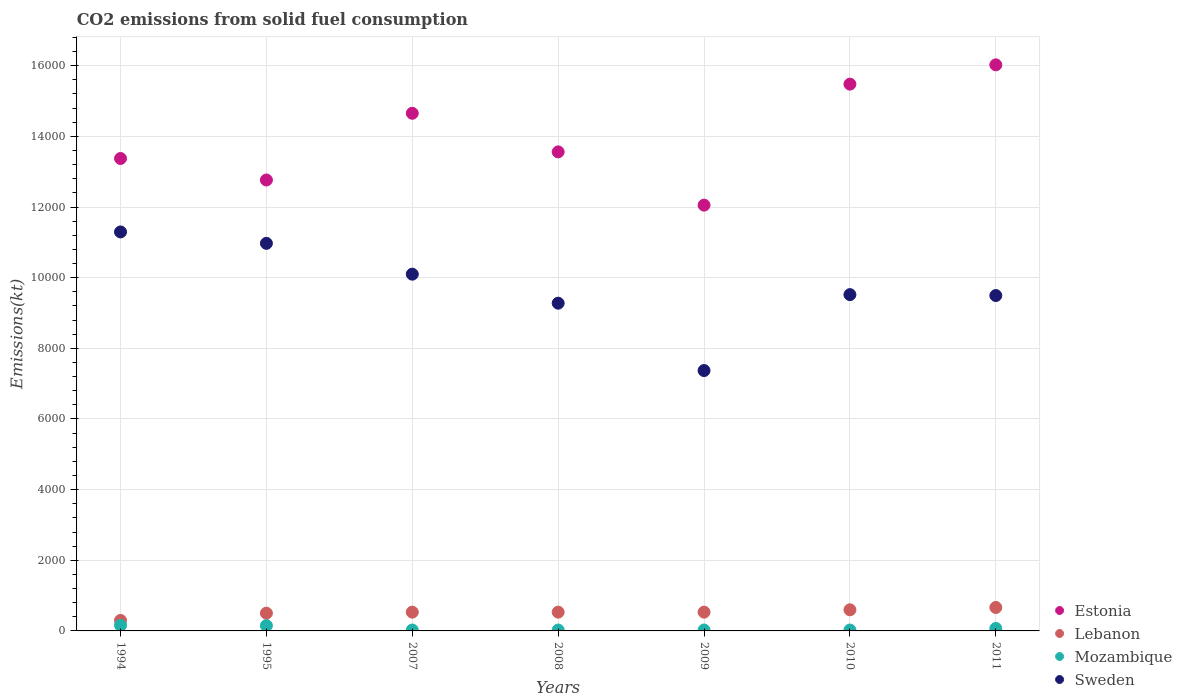How many different coloured dotlines are there?
Offer a terse response. 4. Is the number of dotlines equal to the number of legend labels?
Provide a short and direct response. Yes. What is the amount of CO2 emitted in Estonia in 2008?
Keep it short and to the point. 1.36e+04. Across all years, what is the maximum amount of CO2 emitted in Estonia?
Give a very brief answer. 1.60e+04. Across all years, what is the minimum amount of CO2 emitted in Lebanon?
Make the answer very short. 297.03. In which year was the amount of CO2 emitted in Lebanon minimum?
Offer a terse response. 1994. What is the total amount of CO2 emitted in Sweden in the graph?
Provide a short and direct response. 6.80e+04. What is the difference between the amount of CO2 emitted in Sweden in 2007 and that in 2008?
Your answer should be very brief. 821.41. What is the difference between the amount of CO2 emitted in Sweden in 2011 and the amount of CO2 emitted in Estonia in 2010?
Your answer should be compact. -5984.54. What is the average amount of CO2 emitted in Mozambique per year?
Provide a short and direct response. 68.63. In the year 2008, what is the difference between the amount of CO2 emitted in Estonia and amount of CO2 emitted in Lebanon?
Your answer should be compact. 1.30e+04. In how many years, is the amount of CO2 emitted in Lebanon greater than 8000 kt?
Provide a short and direct response. 0. What is the ratio of the amount of CO2 emitted in Mozambique in 2008 to that in 2010?
Your answer should be compact. 1. Is the amount of CO2 emitted in Mozambique in 2008 less than that in 2011?
Your answer should be very brief. Yes. What is the difference between the highest and the second highest amount of CO2 emitted in Sweden?
Offer a terse response. 322.7. What is the difference between the highest and the lowest amount of CO2 emitted in Sweden?
Offer a very short reply. 3923.69. In how many years, is the amount of CO2 emitted in Sweden greater than the average amount of CO2 emitted in Sweden taken over all years?
Keep it short and to the point. 3. Is the sum of the amount of CO2 emitted in Sweden in 2008 and 2011 greater than the maximum amount of CO2 emitted in Estonia across all years?
Offer a terse response. Yes. Does the amount of CO2 emitted in Estonia monotonically increase over the years?
Give a very brief answer. No. Is the amount of CO2 emitted in Mozambique strictly less than the amount of CO2 emitted in Sweden over the years?
Provide a short and direct response. Yes. How many dotlines are there?
Your answer should be very brief. 4. Does the graph contain any zero values?
Offer a terse response. No. Does the graph contain grids?
Offer a terse response. Yes. Where does the legend appear in the graph?
Offer a terse response. Bottom right. How many legend labels are there?
Offer a very short reply. 4. How are the legend labels stacked?
Provide a short and direct response. Vertical. What is the title of the graph?
Give a very brief answer. CO2 emissions from solid fuel consumption. What is the label or title of the Y-axis?
Provide a succinct answer. Emissions(kt). What is the Emissions(kt) of Estonia in 1994?
Your answer should be compact. 1.34e+04. What is the Emissions(kt) of Lebanon in 1994?
Your response must be concise. 297.03. What is the Emissions(kt) in Mozambique in 1994?
Offer a very short reply. 157.68. What is the Emissions(kt) of Sweden in 1994?
Provide a short and direct response. 1.13e+04. What is the Emissions(kt) in Estonia in 1995?
Your answer should be compact. 1.28e+04. What is the Emissions(kt) of Lebanon in 1995?
Your response must be concise. 502.38. What is the Emissions(kt) in Mozambique in 1995?
Keep it short and to the point. 150.35. What is the Emissions(kt) of Sweden in 1995?
Offer a very short reply. 1.10e+04. What is the Emissions(kt) in Estonia in 2007?
Make the answer very short. 1.47e+04. What is the Emissions(kt) of Lebanon in 2007?
Offer a terse response. 531.72. What is the Emissions(kt) of Mozambique in 2007?
Give a very brief answer. 25.67. What is the Emissions(kt) in Sweden in 2007?
Your answer should be compact. 1.01e+04. What is the Emissions(kt) of Estonia in 2008?
Give a very brief answer. 1.36e+04. What is the Emissions(kt) in Lebanon in 2008?
Provide a succinct answer. 531.72. What is the Emissions(kt) of Mozambique in 2008?
Your response must be concise. 25.67. What is the Emissions(kt) in Sweden in 2008?
Keep it short and to the point. 9277.51. What is the Emissions(kt) in Estonia in 2009?
Provide a short and direct response. 1.21e+04. What is the Emissions(kt) in Lebanon in 2009?
Make the answer very short. 531.72. What is the Emissions(kt) in Mozambique in 2009?
Make the answer very short. 25.67. What is the Emissions(kt) in Sweden in 2009?
Your answer should be compact. 7370.67. What is the Emissions(kt) of Estonia in 2010?
Give a very brief answer. 1.55e+04. What is the Emissions(kt) of Lebanon in 2010?
Your response must be concise. 597.72. What is the Emissions(kt) of Mozambique in 2010?
Give a very brief answer. 25.67. What is the Emissions(kt) in Sweden in 2010?
Your answer should be compact. 9519.53. What is the Emissions(kt) of Estonia in 2011?
Provide a succinct answer. 1.60e+04. What is the Emissions(kt) in Lebanon in 2011?
Provide a succinct answer. 663.73. What is the Emissions(kt) of Mozambique in 2011?
Make the answer very short. 69.67. What is the Emissions(kt) in Sweden in 2011?
Give a very brief answer. 9493.86. Across all years, what is the maximum Emissions(kt) in Estonia?
Ensure brevity in your answer.  1.60e+04. Across all years, what is the maximum Emissions(kt) in Lebanon?
Provide a short and direct response. 663.73. Across all years, what is the maximum Emissions(kt) in Mozambique?
Provide a succinct answer. 157.68. Across all years, what is the maximum Emissions(kt) in Sweden?
Your response must be concise. 1.13e+04. Across all years, what is the minimum Emissions(kt) in Estonia?
Give a very brief answer. 1.21e+04. Across all years, what is the minimum Emissions(kt) in Lebanon?
Your answer should be very brief. 297.03. Across all years, what is the minimum Emissions(kt) of Mozambique?
Give a very brief answer. 25.67. Across all years, what is the minimum Emissions(kt) of Sweden?
Your answer should be very brief. 7370.67. What is the total Emissions(kt) in Estonia in the graph?
Give a very brief answer. 9.79e+04. What is the total Emissions(kt) of Lebanon in the graph?
Ensure brevity in your answer.  3656. What is the total Emissions(kt) in Mozambique in the graph?
Give a very brief answer. 480.38. What is the total Emissions(kt) of Sweden in the graph?
Keep it short and to the point. 6.80e+04. What is the difference between the Emissions(kt) of Estonia in 1994 and that in 1995?
Your response must be concise. 608.72. What is the difference between the Emissions(kt) in Lebanon in 1994 and that in 1995?
Make the answer very short. -205.35. What is the difference between the Emissions(kt) in Mozambique in 1994 and that in 1995?
Keep it short and to the point. 7.33. What is the difference between the Emissions(kt) of Sweden in 1994 and that in 1995?
Provide a succinct answer. 322.7. What is the difference between the Emissions(kt) in Estonia in 1994 and that in 2007?
Make the answer very short. -1279.78. What is the difference between the Emissions(kt) in Lebanon in 1994 and that in 2007?
Offer a very short reply. -234.69. What is the difference between the Emissions(kt) in Mozambique in 1994 and that in 2007?
Offer a very short reply. 132.01. What is the difference between the Emissions(kt) in Sweden in 1994 and that in 2007?
Offer a very short reply. 1195.44. What is the difference between the Emissions(kt) of Estonia in 1994 and that in 2008?
Make the answer very short. -187.02. What is the difference between the Emissions(kt) of Lebanon in 1994 and that in 2008?
Offer a terse response. -234.69. What is the difference between the Emissions(kt) of Mozambique in 1994 and that in 2008?
Offer a very short reply. 132.01. What is the difference between the Emissions(kt) in Sweden in 1994 and that in 2008?
Keep it short and to the point. 2016.85. What is the difference between the Emissions(kt) in Estonia in 1994 and that in 2009?
Keep it short and to the point. 1320.12. What is the difference between the Emissions(kt) in Lebanon in 1994 and that in 2009?
Ensure brevity in your answer.  -234.69. What is the difference between the Emissions(kt) of Mozambique in 1994 and that in 2009?
Offer a terse response. 132.01. What is the difference between the Emissions(kt) in Sweden in 1994 and that in 2009?
Your answer should be very brief. 3923.69. What is the difference between the Emissions(kt) of Estonia in 1994 and that in 2010?
Your answer should be compact. -2104.86. What is the difference between the Emissions(kt) in Lebanon in 1994 and that in 2010?
Offer a very short reply. -300.69. What is the difference between the Emissions(kt) of Mozambique in 1994 and that in 2010?
Your answer should be compact. 132.01. What is the difference between the Emissions(kt) in Sweden in 1994 and that in 2010?
Your answer should be compact. 1774.83. What is the difference between the Emissions(kt) in Estonia in 1994 and that in 2011?
Offer a terse response. -2651.24. What is the difference between the Emissions(kt) of Lebanon in 1994 and that in 2011?
Make the answer very short. -366.7. What is the difference between the Emissions(kt) in Mozambique in 1994 and that in 2011?
Ensure brevity in your answer.  88.01. What is the difference between the Emissions(kt) of Sweden in 1994 and that in 2011?
Keep it short and to the point. 1800.5. What is the difference between the Emissions(kt) in Estonia in 1995 and that in 2007?
Keep it short and to the point. -1888.51. What is the difference between the Emissions(kt) of Lebanon in 1995 and that in 2007?
Offer a very short reply. -29.34. What is the difference between the Emissions(kt) of Mozambique in 1995 and that in 2007?
Provide a succinct answer. 124.68. What is the difference between the Emissions(kt) in Sweden in 1995 and that in 2007?
Your response must be concise. 872.75. What is the difference between the Emissions(kt) of Estonia in 1995 and that in 2008?
Offer a very short reply. -795.74. What is the difference between the Emissions(kt) in Lebanon in 1995 and that in 2008?
Give a very brief answer. -29.34. What is the difference between the Emissions(kt) in Mozambique in 1995 and that in 2008?
Give a very brief answer. 124.68. What is the difference between the Emissions(kt) in Sweden in 1995 and that in 2008?
Offer a terse response. 1694.15. What is the difference between the Emissions(kt) in Estonia in 1995 and that in 2009?
Your answer should be compact. 711.4. What is the difference between the Emissions(kt) in Lebanon in 1995 and that in 2009?
Your response must be concise. -29.34. What is the difference between the Emissions(kt) in Mozambique in 1995 and that in 2009?
Your response must be concise. 124.68. What is the difference between the Emissions(kt) in Sweden in 1995 and that in 2009?
Provide a succinct answer. 3600.99. What is the difference between the Emissions(kt) in Estonia in 1995 and that in 2010?
Ensure brevity in your answer.  -2713.58. What is the difference between the Emissions(kt) in Lebanon in 1995 and that in 2010?
Your response must be concise. -95.34. What is the difference between the Emissions(kt) in Mozambique in 1995 and that in 2010?
Offer a terse response. 124.68. What is the difference between the Emissions(kt) in Sweden in 1995 and that in 2010?
Offer a terse response. 1452.13. What is the difference between the Emissions(kt) of Estonia in 1995 and that in 2011?
Ensure brevity in your answer.  -3259.96. What is the difference between the Emissions(kt) in Lebanon in 1995 and that in 2011?
Ensure brevity in your answer.  -161.35. What is the difference between the Emissions(kt) in Mozambique in 1995 and that in 2011?
Your answer should be very brief. 80.67. What is the difference between the Emissions(kt) in Sweden in 1995 and that in 2011?
Make the answer very short. 1477.8. What is the difference between the Emissions(kt) of Estonia in 2007 and that in 2008?
Your response must be concise. 1092.77. What is the difference between the Emissions(kt) in Mozambique in 2007 and that in 2008?
Offer a terse response. 0. What is the difference between the Emissions(kt) in Sweden in 2007 and that in 2008?
Provide a short and direct response. 821.41. What is the difference between the Emissions(kt) of Estonia in 2007 and that in 2009?
Your answer should be compact. 2599.9. What is the difference between the Emissions(kt) of Sweden in 2007 and that in 2009?
Offer a terse response. 2728.25. What is the difference between the Emissions(kt) of Estonia in 2007 and that in 2010?
Give a very brief answer. -825.08. What is the difference between the Emissions(kt) in Lebanon in 2007 and that in 2010?
Keep it short and to the point. -66.01. What is the difference between the Emissions(kt) in Mozambique in 2007 and that in 2010?
Offer a very short reply. 0. What is the difference between the Emissions(kt) of Sweden in 2007 and that in 2010?
Provide a short and direct response. 579.39. What is the difference between the Emissions(kt) in Estonia in 2007 and that in 2011?
Offer a terse response. -1371.46. What is the difference between the Emissions(kt) in Lebanon in 2007 and that in 2011?
Your answer should be compact. -132.01. What is the difference between the Emissions(kt) in Mozambique in 2007 and that in 2011?
Ensure brevity in your answer.  -44. What is the difference between the Emissions(kt) of Sweden in 2007 and that in 2011?
Your answer should be very brief. 605.05. What is the difference between the Emissions(kt) in Estonia in 2008 and that in 2009?
Offer a very short reply. 1507.14. What is the difference between the Emissions(kt) of Lebanon in 2008 and that in 2009?
Provide a succinct answer. 0. What is the difference between the Emissions(kt) in Mozambique in 2008 and that in 2009?
Provide a succinct answer. 0. What is the difference between the Emissions(kt) of Sweden in 2008 and that in 2009?
Your answer should be compact. 1906.84. What is the difference between the Emissions(kt) in Estonia in 2008 and that in 2010?
Offer a terse response. -1917.84. What is the difference between the Emissions(kt) of Lebanon in 2008 and that in 2010?
Make the answer very short. -66.01. What is the difference between the Emissions(kt) in Mozambique in 2008 and that in 2010?
Give a very brief answer. 0. What is the difference between the Emissions(kt) of Sweden in 2008 and that in 2010?
Offer a very short reply. -242.02. What is the difference between the Emissions(kt) of Estonia in 2008 and that in 2011?
Your answer should be compact. -2464.22. What is the difference between the Emissions(kt) of Lebanon in 2008 and that in 2011?
Give a very brief answer. -132.01. What is the difference between the Emissions(kt) of Mozambique in 2008 and that in 2011?
Your answer should be very brief. -44. What is the difference between the Emissions(kt) in Sweden in 2008 and that in 2011?
Provide a succinct answer. -216.35. What is the difference between the Emissions(kt) of Estonia in 2009 and that in 2010?
Make the answer very short. -3424.98. What is the difference between the Emissions(kt) in Lebanon in 2009 and that in 2010?
Ensure brevity in your answer.  -66.01. What is the difference between the Emissions(kt) of Sweden in 2009 and that in 2010?
Provide a succinct answer. -2148.86. What is the difference between the Emissions(kt) in Estonia in 2009 and that in 2011?
Your answer should be very brief. -3971.36. What is the difference between the Emissions(kt) in Lebanon in 2009 and that in 2011?
Give a very brief answer. -132.01. What is the difference between the Emissions(kt) of Mozambique in 2009 and that in 2011?
Your answer should be compact. -44. What is the difference between the Emissions(kt) of Sweden in 2009 and that in 2011?
Ensure brevity in your answer.  -2123.19. What is the difference between the Emissions(kt) of Estonia in 2010 and that in 2011?
Offer a very short reply. -546.38. What is the difference between the Emissions(kt) in Lebanon in 2010 and that in 2011?
Ensure brevity in your answer.  -66.01. What is the difference between the Emissions(kt) in Mozambique in 2010 and that in 2011?
Your answer should be compact. -44. What is the difference between the Emissions(kt) in Sweden in 2010 and that in 2011?
Your answer should be compact. 25.67. What is the difference between the Emissions(kt) in Estonia in 1994 and the Emissions(kt) in Lebanon in 1995?
Your answer should be compact. 1.29e+04. What is the difference between the Emissions(kt) in Estonia in 1994 and the Emissions(kt) in Mozambique in 1995?
Your answer should be very brief. 1.32e+04. What is the difference between the Emissions(kt) in Estonia in 1994 and the Emissions(kt) in Sweden in 1995?
Provide a succinct answer. 2401.89. What is the difference between the Emissions(kt) of Lebanon in 1994 and the Emissions(kt) of Mozambique in 1995?
Provide a short and direct response. 146.68. What is the difference between the Emissions(kt) of Lebanon in 1994 and the Emissions(kt) of Sweden in 1995?
Offer a very short reply. -1.07e+04. What is the difference between the Emissions(kt) in Mozambique in 1994 and the Emissions(kt) in Sweden in 1995?
Ensure brevity in your answer.  -1.08e+04. What is the difference between the Emissions(kt) of Estonia in 1994 and the Emissions(kt) of Lebanon in 2007?
Keep it short and to the point. 1.28e+04. What is the difference between the Emissions(kt) in Estonia in 1994 and the Emissions(kt) in Mozambique in 2007?
Give a very brief answer. 1.33e+04. What is the difference between the Emissions(kt) of Estonia in 1994 and the Emissions(kt) of Sweden in 2007?
Offer a very short reply. 3274.63. What is the difference between the Emissions(kt) of Lebanon in 1994 and the Emissions(kt) of Mozambique in 2007?
Give a very brief answer. 271.36. What is the difference between the Emissions(kt) of Lebanon in 1994 and the Emissions(kt) of Sweden in 2007?
Offer a terse response. -9801.89. What is the difference between the Emissions(kt) of Mozambique in 1994 and the Emissions(kt) of Sweden in 2007?
Offer a very short reply. -9941.24. What is the difference between the Emissions(kt) in Estonia in 1994 and the Emissions(kt) in Lebanon in 2008?
Your response must be concise. 1.28e+04. What is the difference between the Emissions(kt) in Estonia in 1994 and the Emissions(kt) in Mozambique in 2008?
Keep it short and to the point. 1.33e+04. What is the difference between the Emissions(kt) of Estonia in 1994 and the Emissions(kt) of Sweden in 2008?
Ensure brevity in your answer.  4096.04. What is the difference between the Emissions(kt) in Lebanon in 1994 and the Emissions(kt) in Mozambique in 2008?
Ensure brevity in your answer.  271.36. What is the difference between the Emissions(kt) of Lebanon in 1994 and the Emissions(kt) of Sweden in 2008?
Ensure brevity in your answer.  -8980.48. What is the difference between the Emissions(kt) in Mozambique in 1994 and the Emissions(kt) in Sweden in 2008?
Give a very brief answer. -9119.83. What is the difference between the Emissions(kt) in Estonia in 1994 and the Emissions(kt) in Lebanon in 2009?
Give a very brief answer. 1.28e+04. What is the difference between the Emissions(kt) in Estonia in 1994 and the Emissions(kt) in Mozambique in 2009?
Provide a succinct answer. 1.33e+04. What is the difference between the Emissions(kt) of Estonia in 1994 and the Emissions(kt) of Sweden in 2009?
Your response must be concise. 6002.88. What is the difference between the Emissions(kt) in Lebanon in 1994 and the Emissions(kt) in Mozambique in 2009?
Give a very brief answer. 271.36. What is the difference between the Emissions(kt) of Lebanon in 1994 and the Emissions(kt) of Sweden in 2009?
Provide a short and direct response. -7073.64. What is the difference between the Emissions(kt) in Mozambique in 1994 and the Emissions(kt) in Sweden in 2009?
Ensure brevity in your answer.  -7212.99. What is the difference between the Emissions(kt) in Estonia in 1994 and the Emissions(kt) in Lebanon in 2010?
Your response must be concise. 1.28e+04. What is the difference between the Emissions(kt) in Estonia in 1994 and the Emissions(kt) in Mozambique in 2010?
Offer a very short reply. 1.33e+04. What is the difference between the Emissions(kt) of Estonia in 1994 and the Emissions(kt) of Sweden in 2010?
Provide a succinct answer. 3854.02. What is the difference between the Emissions(kt) in Lebanon in 1994 and the Emissions(kt) in Mozambique in 2010?
Provide a short and direct response. 271.36. What is the difference between the Emissions(kt) of Lebanon in 1994 and the Emissions(kt) of Sweden in 2010?
Offer a very short reply. -9222.5. What is the difference between the Emissions(kt) of Mozambique in 1994 and the Emissions(kt) of Sweden in 2010?
Provide a succinct answer. -9361.85. What is the difference between the Emissions(kt) in Estonia in 1994 and the Emissions(kt) in Lebanon in 2011?
Keep it short and to the point. 1.27e+04. What is the difference between the Emissions(kt) in Estonia in 1994 and the Emissions(kt) in Mozambique in 2011?
Ensure brevity in your answer.  1.33e+04. What is the difference between the Emissions(kt) in Estonia in 1994 and the Emissions(kt) in Sweden in 2011?
Provide a succinct answer. 3879.69. What is the difference between the Emissions(kt) of Lebanon in 1994 and the Emissions(kt) of Mozambique in 2011?
Give a very brief answer. 227.35. What is the difference between the Emissions(kt) in Lebanon in 1994 and the Emissions(kt) in Sweden in 2011?
Give a very brief answer. -9196.84. What is the difference between the Emissions(kt) in Mozambique in 1994 and the Emissions(kt) in Sweden in 2011?
Offer a terse response. -9336.18. What is the difference between the Emissions(kt) of Estonia in 1995 and the Emissions(kt) of Lebanon in 2007?
Provide a succinct answer. 1.22e+04. What is the difference between the Emissions(kt) of Estonia in 1995 and the Emissions(kt) of Mozambique in 2007?
Provide a short and direct response. 1.27e+04. What is the difference between the Emissions(kt) of Estonia in 1995 and the Emissions(kt) of Sweden in 2007?
Provide a succinct answer. 2665.91. What is the difference between the Emissions(kt) of Lebanon in 1995 and the Emissions(kt) of Mozambique in 2007?
Give a very brief answer. 476.71. What is the difference between the Emissions(kt) in Lebanon in 1995 and the Emissions(kt) in Sweden in 2007?
Make the answer very short. -9596.54. What is the difference between the Emissions(kt) of Mozambique in 1995 and the Emissions(kt) of Sweden in 2007?
Your answer should be very brief. -9948.57. What is the difference between the Emissions(kt) of Estonia in 1995 and the Emissions(kt) of Lebanon in 2008?
Provide a succinct answer. 1.22e+04. What is the difference between the Emissions(kt) in Estonia in 1995 and the Emissions(kt) in Mozambique in 2008?
Provide a short and direct response. 1.27e+04. What is the difference between the Emissions(kt) in Estonia in 1995 and the Emissions(kt) in Sweden in 2008?
Provide a succinct answer. 3487.32. What is the difference between the Emissions(kt) of Lebanon in 1995 and the Emissions(kt) of Mozambique in 2008?
Provide a short and direct response. 476.71. What is the difference between the Emissions(kt) in Lebanon in 1995 and the Emissions(kt) in Sweden in 2008?
Offer a very short reply. -8775.13. What is the difference between the Emissions(kt) of Mozambique in 1995 and the Emissions(kt) of Sweden in 2008?
Keep it short and to the point. -9127.16. What is the difference between the Emissions(kt) in Estonia in 1995 and the Emissions(kt) in Lebanon in 2009?
Offer a terse response. 1.22e+04. What is the difference between the Emissions(kt) in Estonia in 1995 and the Emissions(kt) in Mozambique in 2009?
Your answer should be compact. 1.27e+04. What is the difference between the Emissions(kt) of Estonia in 1995 and the Emissions(kt) of Sweden in 2009?
Give a very brief answer. 5394.16. What is the difference between the Emissions(kt) in Lebanon in 1995 and the Emissions(kt) in Mozambique in 2009?
Your answer should be compact. 476.71. What is the difference between the Emissions(kt) in Lebanon in 1995 and the Emissions(kt) in Sweden in 2009?
Keep it short and to the point. -6868.29. What is the difference between the Emissions(kt) of Mozambique in 1995 and the Emissions(kt) of Sweden in 2009?
Give a very brief answer. -7220.32. What is the difference between the Emissions(kt) of Estonia in 1995 and the Emissions(kt) of Lebanon in 2010?
Your answer should be compact. 1.22e+04. What is the difference between the Emissions(kt) of Estonia in 1995 and the Emissions(kt) of Mozambique in 2010?
Give a very brief answer. 1.27e+04. What is the difference between the Emissions(kt) of Estonia in 1995 and the Emissions(kt) of Sweden in 2010?
Make the answer very short. 3245.3. What is the difference between the Emissions(kt) of Lebanon in 1995 and the Emissions(kt) of Mozambique in 2010?
Provide a short and direct response. 476.71. What is the difference between the Emissions(kt) in Lebanon in 1995 and the Emissions(kt) in Sweden in 2010?
Provide a short and direct response. -9017.15. What is the difference between the Emissions(kt) of Mozambique in 1995 and the Emissions(kt) of Sweden in 2010?
Your answer should be compact. -9369.18. What is the difference between the Emissions(kt) of Estonia in 1995 and the Emissions(kt) of Lebanon in 2011?
Your response must be concise. 1.21e+04. What is the difference between the Emissions(kt) in Estonia in 1995 and the Emissions(kt) in Mozambique in 2011?
Your answer should be very brief. 1.27e+04. What is the difference between the Emissions(kt) in Estonia in 1995 and the Emissions(kt) in Sweden in 2011?
Your answer should be very brief. 3270.96. What is the difference between the Emissions(kt) of Lebanon in 1995 and the Emissions(kt) of Mozambique in 2011?
Your answer should be very brief. 432.71. What is the difference between the Emissions(kt) in Lebanon in 1995 and the Emissions(kt) in Sweden in 2011?
Offer a very short reply. -8991.48. What is the difference between the Emissions(kt) of Mozambique in 1995 and the Emissions(kt) of Sweden in 2011?
Ensure brevity in your answer.  -9343.52. What is the difference between the Emissions(kt) in Estonia in 2007 and the Emissions(kt) in Lebanon in 2008?
Provide a short and direct response. 1.41e+04. What is the difference between the Emissions(kt) in Estonia in 2007 and the Emissions(kt) in Mozambique in 2008?
Provide a short and direct response. 1.46e+04. What is the difference between the Emissions(kt) of Estonia in 2007 and the Emissions(kt) of Sweden in 2008?
Your answer should be compact. 5375.82. What is the difference between the Emissions(kt) of Lebanon in 2007 and the Emissions(kt) of Mozambique in 2008?
Provide a succinct answer. 506.05. What is the difference between the Emissions(kt) in Lebanon in 2007 and the Emissions(kt) in Sweden in 2008?
Provide a succinct answer. -8745.8. What is the difference between the Emissions(kt) of Mozambique in 2007 and the Emissions(kt) of Sweden in 2008?
Your answer should be compact. -9251.84. What is the difference between the Emissions(kt) of Estonia in 2007 and the Emissions(kt) of Lebanon in 2009?
Offer a terse response. 1.41e+04. What is the difference between the Emissions(kt) in Estonia in 2007 and the Emissions(kt) in Mozambique in 2009?
Keep it short and to the point. 1.46e+04. What is the difference between the Emissions(kt) in Estonia in 2007 and the Emissions(kt) in Sweden in 2009?
Your response must be concise. 7282.66. What is the difference between the Emissions(kt) of Lebanon in 2007 and the Emissions(kt) of Mozambique in 2009?
Give a very brief answer. 506.05. What is the difference between the Emissions(kt) of Lebanon in 2007 and the Emissions(kt) of Sweden in 2009?
Your answer should be compact. -6838.95. What is the difference between the Emissions(kt) in Mozambique in 2007 and the Emissions(kt) in Sweden in 2009?
Offer a terse response. -7345. What is the difference between the Emissions(kt) in Estonia in 2007 and the Emissions(kt) in Lebanon in 2010?
Keep it short and to the point. 1.41e+04. What is the difference between the Emissions(kt) of Estonia in 2007 and the Emissions(kt) of Mozambique in 2010?
Your response must be concise. 1.46e+04. What is the difference between the Emissions(kt) in Estonia in 2007 and the Emissions(kt) in Sweden in 2010?
Your answer should be compact. 5133.8. What is the difference between the Emissions(kt) in Lebanon in 2007 and the Emissions(kt) in Mozambique in 2010?
Provide a succinct answer. 506.05. What is the difference between the Emissions(kt) of Lebanon in 2007 and the Emissions(kt) of Sweden in 2010?
Give a very brief answer. -8987.82. What is the difference between the Emissions(kt) in Mozambique in 2007 and the Emissions(kt) in Sweden in 2010?
Offer a terse response. -9493.86. What is the difference between the Emissions(kt) in Estonia in 2007 and the Emissions(kt) in Lebanon in 2011?
Your response must be concise. 1.40e+04. What is the difference between the Emissions(kt) of Estonia in 2007 and the Emissions(kt) of Mozambique in 2011?
Provide a succinct answer. 1.46e+04. What is the difference between the Emissions(kt) of Estonia in 2007 and the Emissions(kt) of Sweden in 2011?
Provide a succinct answer. 5159.47. What is the difference between the Emissions(kt) in Lebanon in 2007 and the Emissions(kt) in Mozambique in 2011?
Your answer should be compact. 462.04. What is the difference between the Emissions(kt) of Lebanon in 2007 and the Emissions(kt) of Sweden in 2011?
Your answer should be compact. -8962.15. What is the difference between the Emissions(kt) of Mozambique in 2007 and the Emissions(kt) of Sweden in 2011?
Keep it short and to the point. -9468.19. What is the difference between the Emissions(kt) of Estonia in 2008 and the Emissions(kt) of Lebanon in 2009?
Ensure brevity in your answer.  1.30e+04. What is the difference between the Emissions(kt) of Estonia in 2008 and the Emissions(kt) of Mozambique in 2009?
Give a very brief answer. 1.35e+04. What is the difference between the Emissions(kt) of Estonia in 2008 and the Emissions(kt) of Sweden in 2009?
Your response must be concise. 6189.9. What is the difference between the Emissions(kt) in Lebanon in 2008 and the Emissions(kt) in Mozambique in 2009?
Ensure brevity in your answer.  506.05. What is the difference between the Emissions(kt) of Lebanon in 2008 and the Emissions(kt) of Sweden in 2009?
Offer a terse response. -6838.95. What is the difference between the Emissions(kt) in Mozambique in 2008 and the Emissions(kt) in Sweden in 2009?
Give a very brief answer. -7345. What is the difference between the Emissions(kt) of Estonia in 2008 and the Emissions(kt) of Lebanon in 2010?
Make the answer very short. 1.30e+04. What is the difference between the Emissions(kt) of Estonia in 2008 and the Emissions(kt) of Mozambique in 2010?
Offer a very short reply. 1.35e+04. What is the difference between the Emissions(kt) in Estonia in 2008 and the Emissions(kt) in Sweden in 2010?
Offer a terse response. 4041.03. What is the difference between the Emissions(kt) of Lebanon in 2008 and the Emissions(kt) of Mozambique in 2010?
Offer a terse response. 506.05. What is the difference between the Emissions(kt) in Lebanon in 2008 and the Emissions(kt) in Sweden in 2010?
Offer a terse response. -8987.82. What is the difference between the Emissions(kt) in Mozambique in 2008 and the Emissions(kt) in Sweden in 2010?
Your response must be concise. -9493.86. What is the difference between the Emissions(kt) in Estonia in 2008 and the Emissions(kt) in Lebanon in 2011?
Give a very brief answer. 1.29e+04. What is the difference between the Emissions(kt) of Estonia in 2008 and the Emissions(kt) of Mozambique in 2011?
Make the answer very short. 1.35e+04. What is the difference between the Emissions(kt) of Estonia in 2008 and the Emissions(kt) of Sweden in 2011?
Keep it short and to the point. 4066.7. What is the difference between the Emissions(kt) of Lebanon in 2008 and the Emissions(kt) of Mozambique in 2011?
Offer a very short reply. 462.04. What is the difference between the Emissions(kt) in Lebanon in 2008 and the Emissions(kt) in Sweden in 2011?
Your response must be concise. -8962.15. What is the difference between the Emissions(kt) of Mozambique in 2008 and the Emissions(kt) of Sweden in 2011?
Offer a very short reply. -9468.19. What is the difference between the Emissions(kt) in Estonia in 2009 and the Emissions(kt) in Lebanon in 2010?
Make the answer very short. 1.15e+04. What is the difference between the Emissions(kt) in Estonia in 2009 and the Emissions(kt) in Mozambique in 2010?
Offer a terse response. 1.20e+04. What is the difference between the Emissions(kt) of Estonia in 2009 and the Emissions(kt) of Sweden in 2010?
Ensure brevity in your answer.  2533.9. What is the difference between the Emissions(kt) of Lebanon in 2009 and the Emissions(kt) of Mozambique in 2010?
Offer a terse response. 506.05. What is the difference between the Emissions(kt) in Lebanon in 2009 and the Emissions(kt) in Sweden in 2010?
Give a very brief answer. -8987.82. What is the difference between the Emissions(kt) in Mozambique in 2009 and the Emissions(kt) in Sweden in 2010?
Offer a terse response. -9493.86. What is the difference between the Emissions(kt) in Estonia in 2009 and the Emissions(kt) in Lebanon in 2011?
Provide a succinct answer. 1.14e+04. What is the difference between the Emissions(kt) in Estonia in 2009 and the Emissions(kt) in Mozambique in 2011?
Offer a very short reply. 1.20e+04. What is the difference between the Emissions(kt) in Estonia in 2009 and the Emissions(kt) in Sweden in 2011?
Provide a succinct answer. 2559.57. What is the difference between the Emissions(kt) of Lebanon in 2009 and the Emissions(kt) of Mozambique in 2011?
Offer a very short reply. 462.04. What is the difference between the Emissions(kt) in Lebanon in 2009 and the Emissions(kt) in Sweden in 2011?
Ensure brevity in your answer.  -8962.15. What is the difference between the Emissions(kt) of Mozambique in 2009 and the Emissions(kt) of Sweden in 2011?
Give a very brief answer. -9468.19. What is the difference between the Emissions(kt) of Estonia in 2010 and the Emissions(kt) of Lebanon in 2011?
Your response must be concise. 1.48e+04. What is the difference between the Emissions(kt) of Estonia in 2010 and the Emissions(kt) of Mozambique in 2011?
Give a very brief answer. 1.54e+04. What is the difference between the Emissions(kt) in Estonia in 2010 and the Emissions(kt) in Sweden in 2011?
Your answer should be very brief. 5984.54. What is the difference between the Emissions(kt) in Lebanon in 2010 and the Emissions(kt) in Mozambique in 2011?
Make the answer very short. 528.05. What is the difference between the Emissions(kt) of Lebanon in 2010 and the Emissions(kt) of Sweden in 2011?
Your answer should be compact. -8896.14. What is the difference between the Emissions(kt) of Mozambique in 2010 and the Emissions(kt) of Sweden in 2011?
Ensure brevity in your answer.  -9468.19. What is the average Emissions(kt) in Estonia per year?
Offer a very short reply. 1.40e+04. What is the average Emissions(kt) in Lebanon per year?
Make the answer very short. 522.29. What is the average Emissions(kt) of Mozambique per year?
Provide a short and direct response. 68.63. What is the average Emissions(kt) in Sweden per year?
Ensure brevity in your answer.  9718.07. In the year 1994, what is the difference between the Emissions(kt) of Estonia and Emissions(kt) of Lebanon?
Your answer should be very brief. 1.31e+04. In the year 1994, what is the difference between the Emissions(kt) of Estonia and Emissions(kt) of Mozambique?
Your answer should be compact. 1.32e+04. In the year 1994, what is the difference between the Emissions(kt) in Estonia and Emissions(kt) in Sweden?
Offer a very short reply. 2079.19. In the year 1994, what is the difference between the Emissions(kt) of Lebanon and Emissions(kt) of Mozambique?
Keep it short and to the point. 139.35. In the year 1994, what is the difference between the Emissions(kt) in Lebanon and Emissions(kt) in Sweden?
Ensure brevity in your answer.  -1.10e+04. In the year 1994, what is the difference between the Emissions(kt) in Mozambique and Emissions(kt) in Sweden?
Your answer should be very brief. -1.11e+04. In the year 1995, what is the difference between the Emissions(kt) in Estonia and Emissions(kt) in Lebanon?
Give a very brief answer. 1.23e+04. In the year 1995, what is the difference between the Emissions(kt) of Estonia and Emissions(kt) of Mozambique?
Provide a short and direct response. 1.26e+04. In the year 1995, what is the difference between the Emissions(kt) of Estonia and Emissions(kt) of Sweden?
Make the answer very short. 1793.16. In the year 1995, what is the difference between the Emissions(kt) in Lebanon and Emissions(kt) in Mozambique?
Your answer should be very brief. 352.03. In the year 1995, what is the difference between the Emissions(kt) of Lebanon and Emissions(kt) of Sweden?
Ensure brevity in your answer.  -1.05e+04. In the year 1995, what is the difference between the Emissions(kt) of Mozambique and Emissions(kt) of Sweden?
Your answer should be very brief. -1.08e+04. In the year 2007, what is the difference between the Emissions(kt) in Estonia and Emissions(kt) in Lebanon?
Keep it short and to the point. 1.41e+04. In the year 2007, what is the difference between the Emissions(kt) in Estonia and Emissions(kt) in Mozambique?
Keep it short and to the point. 1.46e+04. In the year 2007, what is the difference between the Emissions(kt) in Estonia and Emissions(kt) in Sweden?
Provide a short and direct response. 4554.41. In the year 2007, what is the difference between the Emissions(kt) in Lebanon and Emissions(kt) in Mozambique?
Your answer should be very brief. 506.05. In the year 2007, what is the difference between the Emissions(kt) in Lebanon and Emissions(kt) in Sweden?
Offer a terse response. -9567.2. In the year 2007, what is the difference between the Emissions(kt) in Mozambique and Emissions(kt) in Sweden?
Ensure brevity in your answer.  -1.01e+04. In the year 2008, what is the difference between the Emissions(kt) of Estonia and Emissions(kt) of Lebanon?
Offer a terse response. 1.30e+04. In the year 2008, what is the difference between the Emissions(kt) of Estonia and Emissions(kt) of Mozambique?
Provide a succinct answer. 1.35e+04. In the year 2008, what is the difference between the Emissions(kt) of Estonia and Emissions(kt) of Sweden?
Offer a very short reply. 4283.06. In the year 2008, what is the difference between the Emissions(kt) in Lebanon and Emissions(kt) in Mozambique?
Your answer should be compact. 506.05. In the year 2008, what is the difference between the Emissions(kt) in Lebanon and Emissions(kt) in Sweden?
Offer a very short reply. -8745.8. In the year 2008, what is the difference between the Emissions(kt) in Mozambique and Emissions(kt) in Sweden?
Ensure brevity in your answer.  -9251.84. In the year 2009, what is the difference between the Emissions(kt) in Estonia and Emissions(kt) in Lebanon?
Offer a very short reply. 1.15e+04. In the year 2009, what is the difference between the Emissions(kt) in Estonia and Emissions(kt) in Mozambique?
Make the answer very short. 1.20e+04. In the year 2009, what is the difference between the Emissions(kt) of Estonia and Emissions(kt) of Sweden?
Offer a terse response. 4682.76. In the year 2009, what is the difference between the Emissions(kt) in Lebanon and Emissions(kt) in Mozambique?
Provide a short and direct response. 506.05. In the year 2009, what is the difference between the Emissions(kt) of Lebanon and Emissions(kt) of Sweden?
Make the answer very short. -6838.95. In the year 2009, what is the difference between the Emissions(kt) in Mozambique and Emissions(kt) in Sweden?
Keep it short and to the point. -7345. In the year 2010, what is the difference between the Emissions(kt) in Estonia and Emissions(kt) in Lebanon?
Offer a terse response. 1.49e+04. In the year 2010, what is the difference between the Emissions(kt) of Estonia and Emissions(kt) of Mozambique?
Your response must be concise. 1.55e+04. In the year 2010, what is the difference between the Emissions(kt) of Estonia and Emissions(kt) of Sweden?
Provide a succinct answer. 5958.88. In the year 2010, what is the difference between the Emissions(kt) of Lebanon and Emissions(kt) of Mozambique?
Make the answer very short. 572.05. In the year 2010, what is the difference between the Emissions(kt) of Lebanon and Emissions(kt) of Sweden?
Your answer should be compact. -8921.81. In the year 2010, what is the difference between the Emissions(kt) in Mozambique and Emissions(kt) in Sweden?
Your answer should be compact. -9493.86. In the year 2011, what is the difference between the Emissions(kt) of Estonia and Emissions(kt) of Lebanon?
Your answer should be compact. 1.54e+04. In the year 2011, what is the difference between the Emissions(kt) of Estonia and Emissions(kt) of Mozambique?
Your response must be concise. 1.60e+04. In the year 2011, what is the difference between the Emissions(kt) in Estonia and Emissions(kt) in Sweden?
Provide a short and direct response. 6530.93. In the year 2011, what is the difference between the Emissions(kt) in Lebanon and Emissions(kt) in Mozambique?
Provide a short and direct response. 594.05. In the year 2011, what is the difference between the Emissions(kt) of Lebanon and Emissions(kt) of Sweden?
Ensure brevity in your answer.  -8830.14. In the year 2011, what is the difference between the Emissions(kt) in Mozambique and Emissions(kt) in Sweden?
Offer a very short reply. -9424.19. What is the ratio of the Emissions(kt) in Estonia in 1994 to that in 1995?
Ensure brevity in your answer.  1.05. What is the ratio of the Emissions(kt) of Lebanon in 1994 to that in 1995?
Make the answer very short. 0.59. What is the ratio of the Emissions(kt) of Mozambique in 1994 to that in 1995?
Your answer should be very brief. 1.05. What is the ratio of the Emissions(kt) of Sweden in 1994 to that in 1995?
Provide a short and direct response. 1.03. What is the ratio of the Emissions(kt) in Estonia in 1994 to that in 2007?
Make the answer very short. 0.91. What is the ratio of the Emissions(kt) in Lebanon in 1994 to that in 2007?
Your answer should be compact. 0.56. What is the ratio of the Emissions(kt) in Mozambique in 1994 to that in 2007?
Provide a succinct answer. 6.14. What is the ratio of the Emissions(kt) of Sweden in 1994 to that in 2007?
Offer a very short reply. 1.12. What is the ratio of the Emissions(kt) in Estonia in 1994 to that in 2008?
Give a very brief answer. 0.99. What is the ratio of the Emissions(kt) of Lebanon in 1994 to that in 2008?
Your answer should be compact. 0.56. What is the ratio of the Emissions(kt) of Mozambique in 1994 to that in 2008?
Provide a short and direct response. 6.14. What is the ratio of the Emissions(kt) in Sweden in 1994 to that in 2008?
Give a very brief answer. 1.22. What is the ratio of the Emissions(kt) in Estonia in 1994 to that in 2009?
Offer a terse response. 1.11. What is the ratio of the Emissions(kt) in Lebanon in 1994 to that in 2009?
Keep it short and to the point. 0.56. What is the ratio of the Emissions(kt) in Mozambique in 1994 to that in 2009?
Provide a short and direct response. 6.14. What is the ratio of the Emissions(kt) of Sweden in 1994 to that in 2009?
Make the answer very short. 1.53. What is the ratio of the Emissions(kt) in Estonia in 1994 to that in 2010?
Give a very brief answer. 0.86. What is the ratio of the Emissions(kt) in Lebanon in 1994 to that in 2010?
Your answer should be compact. 0.5. What is the ratio of the Emissions(kt) of Mozambique in 1994 to that in 2010?
Give a very brief answer. 6.14. What is the ratio of the Emissions(kt) of Sweden in 1994 to that in 2010?
Offer a very short reply. 1.19. What is the ratio of the Emissions(kt) in Estonia in 1994 to that in 2011?
Your response must be concise. 0.83. What is the ratio of the Emissions(kt) in Lebanon in 1994 to that in 2011?
Provide a short and direct response. 0.45. What is the ratio of the Emissions(kt) of Mozambique in 1994 to that in 2011?
Keep it short and to the point. 2.26. What is the ratio of the Emissions(kt) of Sweden in 1994 to that in 2011?
Offer a terse response. 1.19. What is the ratio of the Emissions(kt) in Estonia in 1995 to that in 2007?
Make the answer very short. 0.87. What is the ratio of the Emissions(kt) of Lebanon in 1995 to that in 2007?
Offer a terse response. 0.94. What is the ratio of the Emissions(kt) of Mozambique in 1995 to that in 2007?
Your answer should be compact. 5.86. What is the ratio of the Emissions(kt) of Sweden in 1995 to that in 2007?
Your response must be concise. 1.09. What is the ratio of the Emissions(kt) of Estonia in 1995 to that in 2008?
Ensure brevity in your answer.  0.94. What is the ratio of the Emissions(kt) in Lebanon in 1995 to that in 2008?
Provide a short and direct response. 0.94. What is the ratio of the Emissions(kt) of Mozambique in 1995 to that in 2008?
Your response must be concise. 5.86. What is the ratio of the Emissions(kt) in Sweden in 1995 to that in 2008?
Give a very brief answer. 1.18. What is the ratio of the Emissions(kt) in Estonia in 1995 to that in 2009?
Offer a terse response. 1.06. What is the ratio of the Emissions(kt) in Lebanon in 1995 to that in 2009?
Provide a succinct answer. 0.94. What is the ratio of the Emissions(kt) of Mozambique in 1995 to that in 2009?
Make the answer very short. 5.86. What is the ratio of the Emissions(kt) of Sweden in 1995 to that in 2009?
Your response must be concise. 1.49. What is the ratio of the Emissions(kt) of Estonia in 1995 to that in 2010?
Ensure brevity in your answer.  0.82. What is the ratio of the Emissions(kt) in Lebanon in 1995 to that in 2010?
Give a very brief answer. 0.84. What is the ratio of the Emissions(kt) in Mozambique in 1995 to that in 2010?
Keep it short and to the point. 5.86. What is the ratio of the Emissions(kt) in Sweden in 1995 to that in 2010?
Offer a terse response. 1.15. What is the ratio of the Emissions(kt) of Estonia in 1995 to that in 2011?
Ensure brevity in your answer.  0.8. What is the ratio of the Emissions(kt) of Lebanon in 1995 to that in 2011?
Ensure brevity in your answer.  0.76. What is the ratio of the Emissions(kt) of Mozambique in 1995 to that in 2011?
Give a very brief answer. 2.16. What is the ratio of the Emissions(kt) in Sweden in 1995 to that in 2011?
Offer a very short reply. 1.16. What is the ratio of the Emissions(kt) in Estonia in 2007 to that in 2008?
Make the answer very short. 1.08. What is the ratio of the Emissions(kt) of Lebanon in 2007 to that in 2008?
Keep it short and to the point. 1. What is the ratio of the Emissions(kt) of Mozambique in 2007 to that in 2008?
Your answer should be compact. 1. What is the ratio of the Emissions(kt) in Sweden in 2007 to that in 2008?
Make the answer very short. 1.09. What is the ratio of the Emissions(kt) in Estonia in 2007 to that in 2009?
Make the answer very short. 1.22. What is the ratio of the Emissions(kt) in Sweden in 2007 to that in 2009?
Your answer should be compact. 1.37. What is the ratio of the Emissions(kt) of Estonia in 2007 to that in 2010?
Offer a very short reply. 0.95. What is the ratio of the Emissions(kt) of Lebanon in 2007 to that in 2010?
Your answer should be very brief. 0.89. What is the ratio of the Emissions(kt) of Sweden in 2007 to that in 2010?
Your response must be concise. 1.06. What is the ratio of the Emissions(kt) of Estonia in 2007 to that in 2011?
Provide a short and direct response. 0.91. What is the ratio of the Emissions(kt) in Lebanon in 2007 to that in 2011?
Give a very brief answer. 0.8. What is the ratio of the Emissions(kt) in Mozambique in 2007 to that in 2011?
Your response must be concise. 0.37. What is the ratio of the Emissions(kt) in Sweden in 2007 to that in 2011?
Your answer should be compact. 1.06. What is the ratio of the Emissions(kt) in Estonia in 2008 to that in 2009?
Provide a succinct answer. 1.12. What is the ratio of the Emissions(kt) of Mozambique in 2008 to that in 2009?
Provide a short and direct response. 1. What is the ratio of the Emissions(kt) of Sweden in 2008 to that in 2009?
Provide a short and direct response. 1.26. What is the ratio of the Emissions(kt) of Estonia in 2008 to that in 2010?
Offer a terse response. 0.88. What is the ratio of the Emissions(kt) in Lebanon in 2008 to that in 2010?
Provide a short and direct response. 0.89. What is the ratio of the Emissions(kt) in Mozambique in 2008 to that in 2010?
Your response must be concise. 1. What is the ratio of the Emissions(kt) in Sweden in 2008 to that in 2010?
Give a very brief answer. 0.97. What is the ratio of the Emissions(kt) of Estonia in 2008 to that in 2011?
Ensure brevity in your answer.  0.85. What is the ratio of the Emissions(kt) of Lebanon in 2008 to that in 2011?
Ensure brevity in your answer.  0.8. What is the ratio of the Emissions(kt) in Mozambique in 2008 to that in 2011?
Provide a short and direct response. 0.37. What is the ratio of the Emissions(kt) of Sweden in 2008 to that in 2011?
Offer a terse response. 0.98. What is the ratio of the Emissions(kt) in Estonia in 2009 to that in 2010?
Offer a terse response. 0.78. What is the ratio of the Emissions(kt) in Lebanon in 2009 to that in 2010?
Provide a short and direct response. 0.89. What is the ratio of the Emissions(kt) in Mozambique in 2009 to that in 2010?
Your answer should be very brief. 1. What is the ratio of the Emissions(kt) in Sweden in 2009 to that in 2010?
Keep it short and to the point. 0.77. What is the ratio of the Emissions(kt) in Estonia in 2009 to that in 2011?
Provide a succinct answer. 0.75. What is the ratio of the Emissions(kt) in Lebanon in 2009 to that in 2011?
Provide a succinct answer. 0.8. What is the ratio of the Emissions(kt) in Mozambique in 2009 to that in 2011?
Your answer should be compact. 0.37. What is the ratio of the Emissions(kt) in Sweden in 2009 to that in 2011?
Offer a terse response. 0.78. What is the ratio of the Emissions(kt) of Estonia in 2010 to that in 2011?
Provide a short and direct response. 0.97. What is the ratio of the Emissions(kt) of Lebanon in 2010 to that in 2011?
Make the answer very short. 0.9. What is the ratio of the Emissions(kt) of Mozambique in 2010 to that in 2011?
Your answer should be compact. 0.37. What is the difference between the highest and the second highest Emissions(kt) in Estonia?
Your response must be concise. 546.38. What is the difference between the highest and the second highest Emissions(kt) in Lebanon?
Your response must be concise. 66.01. What is the difference between the highest and the second highest Emissions(kt) in Mozambique?
Ensure brevity in your answer.  7.33. What is the difference between the highest and the second highest Emissions(kt) in Sweden?
Your answer should be very brief. 322.7. What is the difference between the highest and the lowest Emissions(kt) in Estonia?
Give a very brief answer. 3971.36. What is the difference between the highest and the lowest Emissions(kt) in Lebanon?
Ensure brevity in your answer.  366.7. What is the difference between the highest and the lowest Emissions(kt) of Mozambique?
Offer a very short reply. 132.01. What is the difference between the highest and the lowest Emissions(kt) in Sweden?
Your response must be concise. 3923.69. 